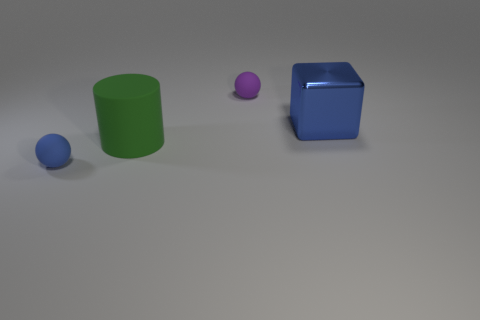How might the size of the objects affect their perceived weight? Assuming the objects are made from the same material, their size would suggest that the larger objects are heavier. However, without knowing the actual material, this is speculative. 